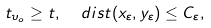<formula> <loc_0><loc_0><loc_500><loc_500>t _ { \upsilon _ { o } } \geq t , \ \ d i s t ( x _ { \varepsilon } , y _ { \varepsilon } ) \leq C _ { \varepsilon } ,</formula> 